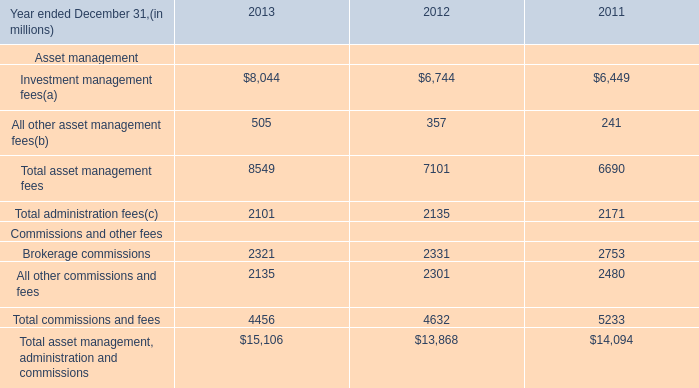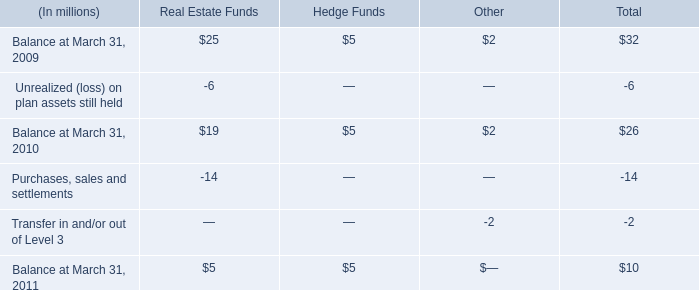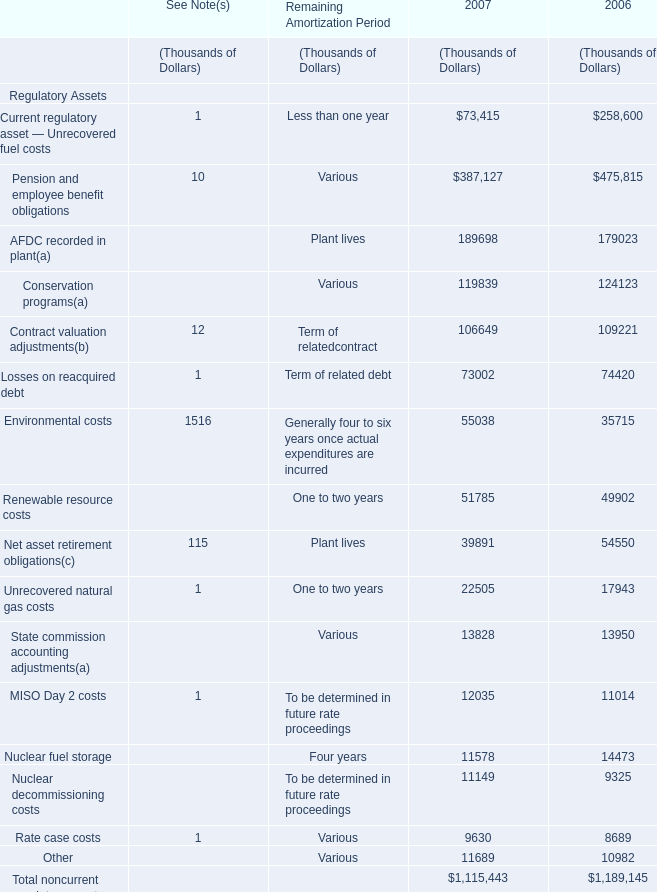In which section the sum of Contract valuation adjustments( has the highest value? 
Answer: 2006. 